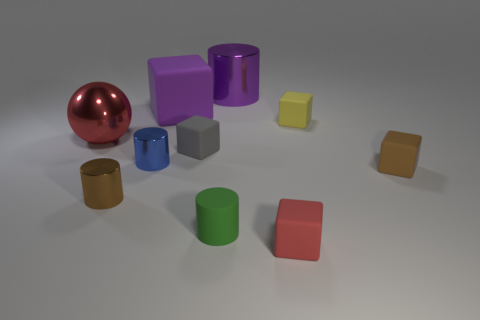Subtract all large purple cylinders. How many cylinders are left? 3 Subtract all cylinders. How many objects are left? 6 Subtract all purple cylinders. How many cylinders are left? 3 Subtract 4 cylinders. How many cylinders are left? 0 Add 3 small brown shiny things. How many small brown shiny things are left? 4 Add 1 tiny green balls. How many tiny green balls exist? 1 Subtract 0 cyan blocks. How many objects are left? 10 Subtract all green balls. Subtract all blue cylinders. How many balls are left? 1 Subtract all cylinders. Subtract all red metal balls. How many objects are left? 5 